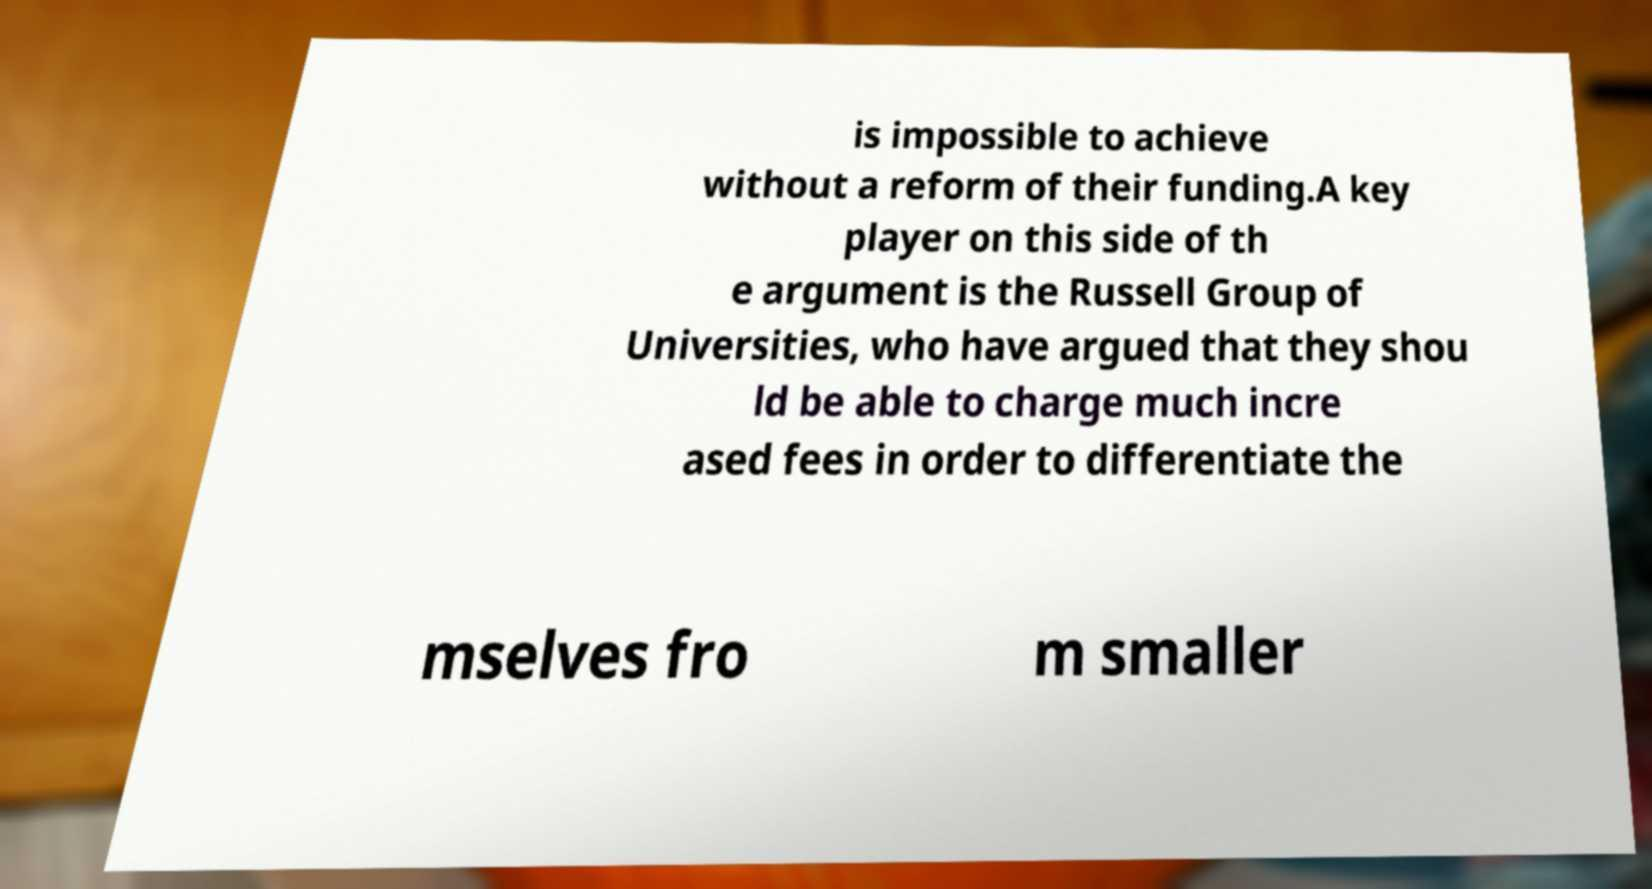Could you assist in decoding the text presented in this image and type it out clearly? is impossible to achieve without a reform of their funding.A key player on this side of th e argument is the Russell Group of Universities, who have argued that they shou ld be able to charge much incre ased fees in order to differentiate the mselves fro m smaller 